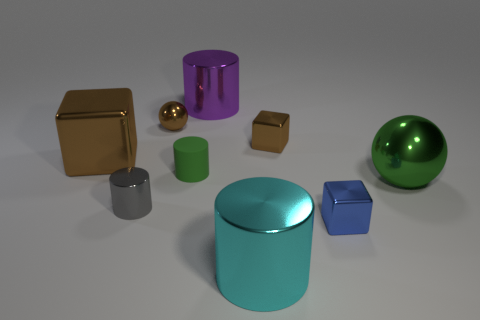There is a brown metal thing that is on the right side of the brown metal sphere left of the large cyan metallic object; what is its size?
Your answer should be very brief. Small. There is another cube that is the same color as the big metal cube; what size is it?
Your response must be concise. Small. How many other things are the same size as the blue metal block?
Offer a very short reply. 4. There is a shiny sphere on the left side of the big purple cylinder behind the brown cube that is to the left of the big purple metal object; what is its color?
Your answer should be very brief. Brown. What number of other objects are there of the same shape as the tiny gray thing?
Offer a very short reply. 3. What shape is the tiny brown object on the left side of the matte object?
Your answer should be very brief. Sphere. There is a tiny brown metal thing that is right of the large purple metal cylinder; is there a blue thing behind it?
Keep it short and to the point. No. What color is the metallic thing that is in front of the gray object and to the left of the tiny blue shiny thing?
Give a very brief answer. Cyan. Is there a large green object left of the large metallic cylinder that is behind the big cylinder in front of the tiny green object?
Make the answer very short. No. There is a purple shiny thing that is the same shape as the cyan object; what size is it?
Give a very brief answer. Large. 